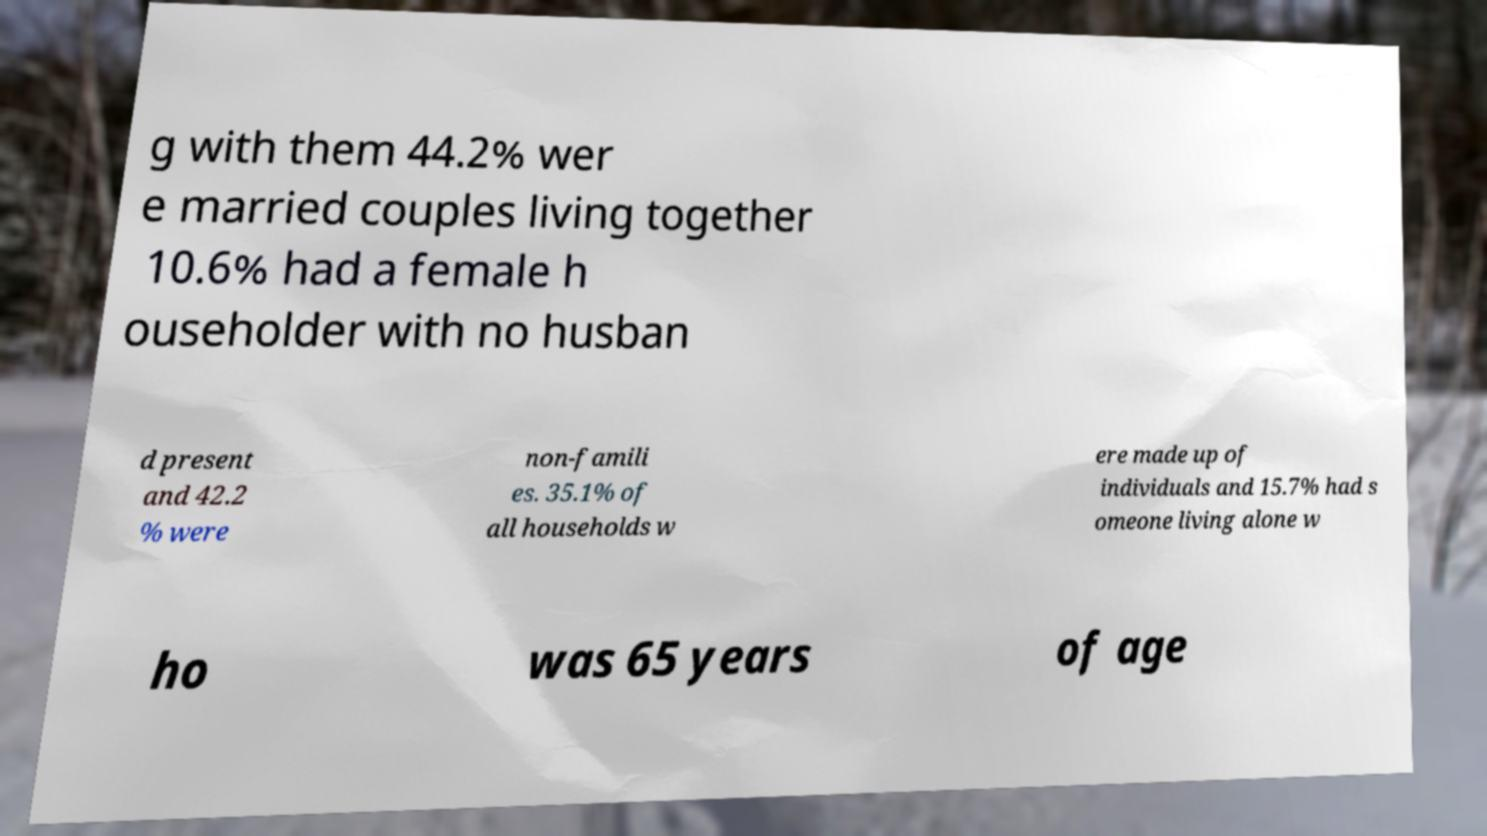For documentation purposes, I need the text within this image transcribed. Could you provide that? g with them 44.2% wer e married couples living together 10.6% had a female h ouseholder with no husban d present and 42.2 % were non-famili es. 35.1% of all households w ere made up of individuals and 15.7% had s omeone living alone w ho was 65 years of age 